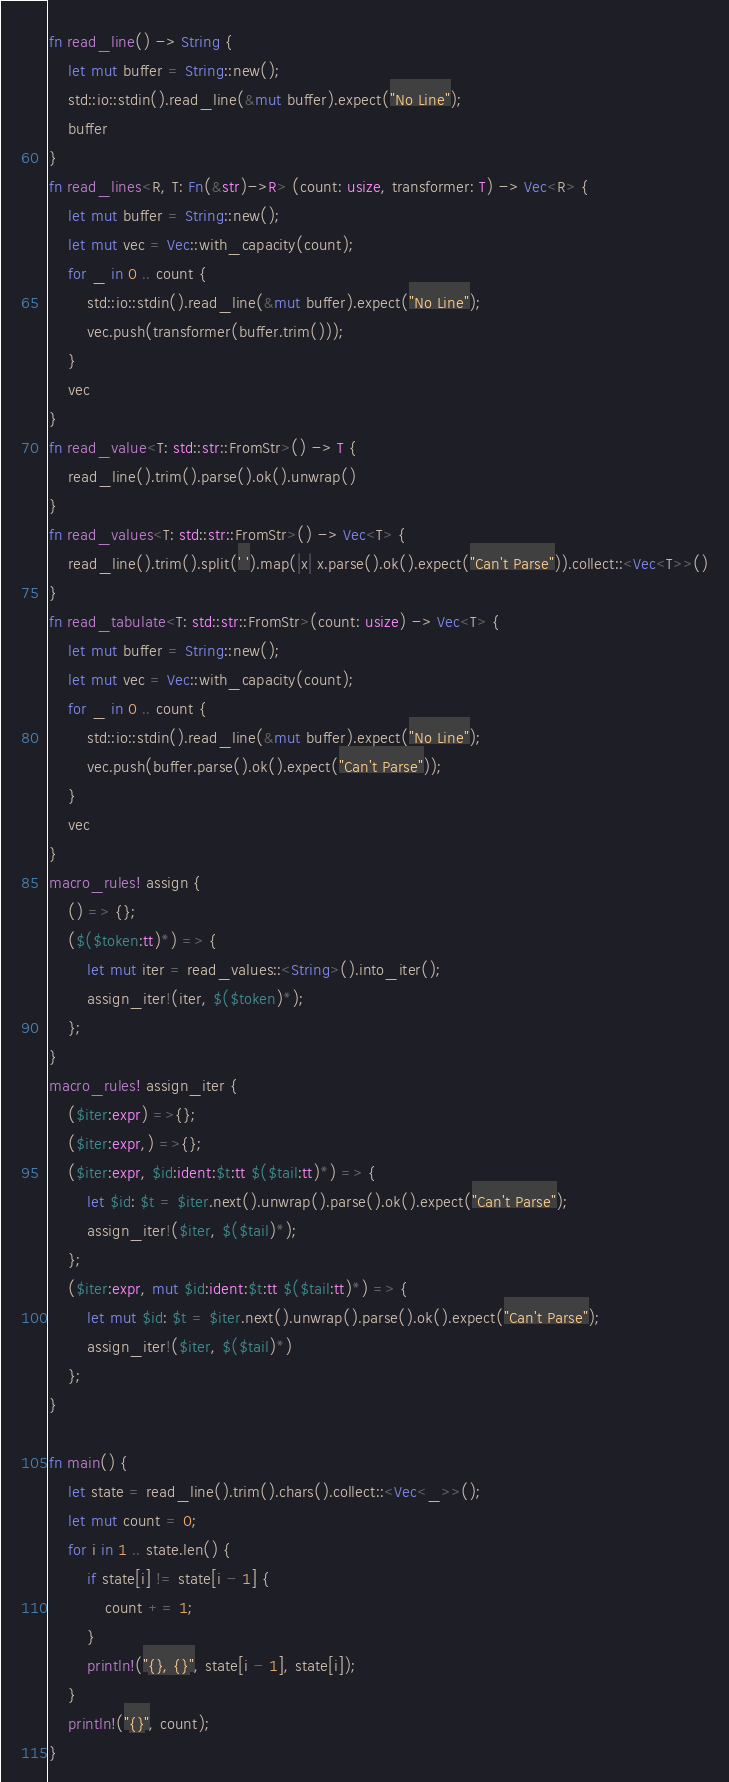<code> <loc_0><loc_0><loc_500><loc_500><_Rust_>fn read_line() -> String {
    let mut buffer = String::new();
    std::io::stdin().read_line(&mut buffer).expect("No Line");
    buffer
}
fn read_lines<R, T: Fn(&str)->R> (count: usize, transformer: T) -> Vec<R> {
    let mut buffer = String::new();
    let mut vec = Vec::with_capacity(count);
    for _ in 0 .. count {
        std::io::stdin().read_line(&mut buffer).expect("No Line");
        vec.push(transformer(buffer.trim()));
    }
    vec
}
fn read_value<T: std::str::FromStr>() -> T {
    read_line().trim().parse().ok().unwrap()
}
fn read_values<T: std::str::FromStr>() -> Vec<T> {
    read_line().trim().split(' ').map(|x| x.parse().ok().expect("Can't Parse")).collect::<Vec<T>>()
}
fn read_tabulate<T: std::str::FromStr>(count: usize) -> Vec<T> {
    let mut buffer = String::new();
    let mut vec = Vec::with_capacity(count);
    for _ in 0 .. count {
        std::io::stdin().read_line(&mut buffer).expect("No Line");
        vec.push(buffer.parse().ok().expect("Can't Parse"));
    }
    vec
}
macro_rules! assign {
    () => {};
    ($($token:tt)*) => {
        let mut iter = read_values::<String>().into_iter();
        assign_iter!(iter, $($token)*);
    };
}
macro_rules! assign_iter {
    ($iter:expr) =>{};
    ($iter:expr,) =>{};
    ($iter:expr, $id:ident:$t:tt $($tail:tt)*) => {
        let $id: $t = $iter.next().unwrap().parse().ok().expect("Can't Parse");
        assign_iter!($iter, $($tail)*);
    };
    ($iter:expr, mut $id:ident:$t:tt $($tail:tt)*) => {
        let mut $id: $t = $iter.next().unwrap().parse().ok().expect("Can't Parse");
        assign_iter!($iter, $($tail)*)
    };
}

fn main() {
    let state = read_line().trim().chars().collect::<Vec<_>>();
    let mut count = 0;
    for i in 1 .. state.len() {
        if state[i] != state[i - 1] {
            count += 1;
        }
        println!("{}, {}", state[i - 1], state[i]);
    }
    println!("{}", count);
}
</code> 